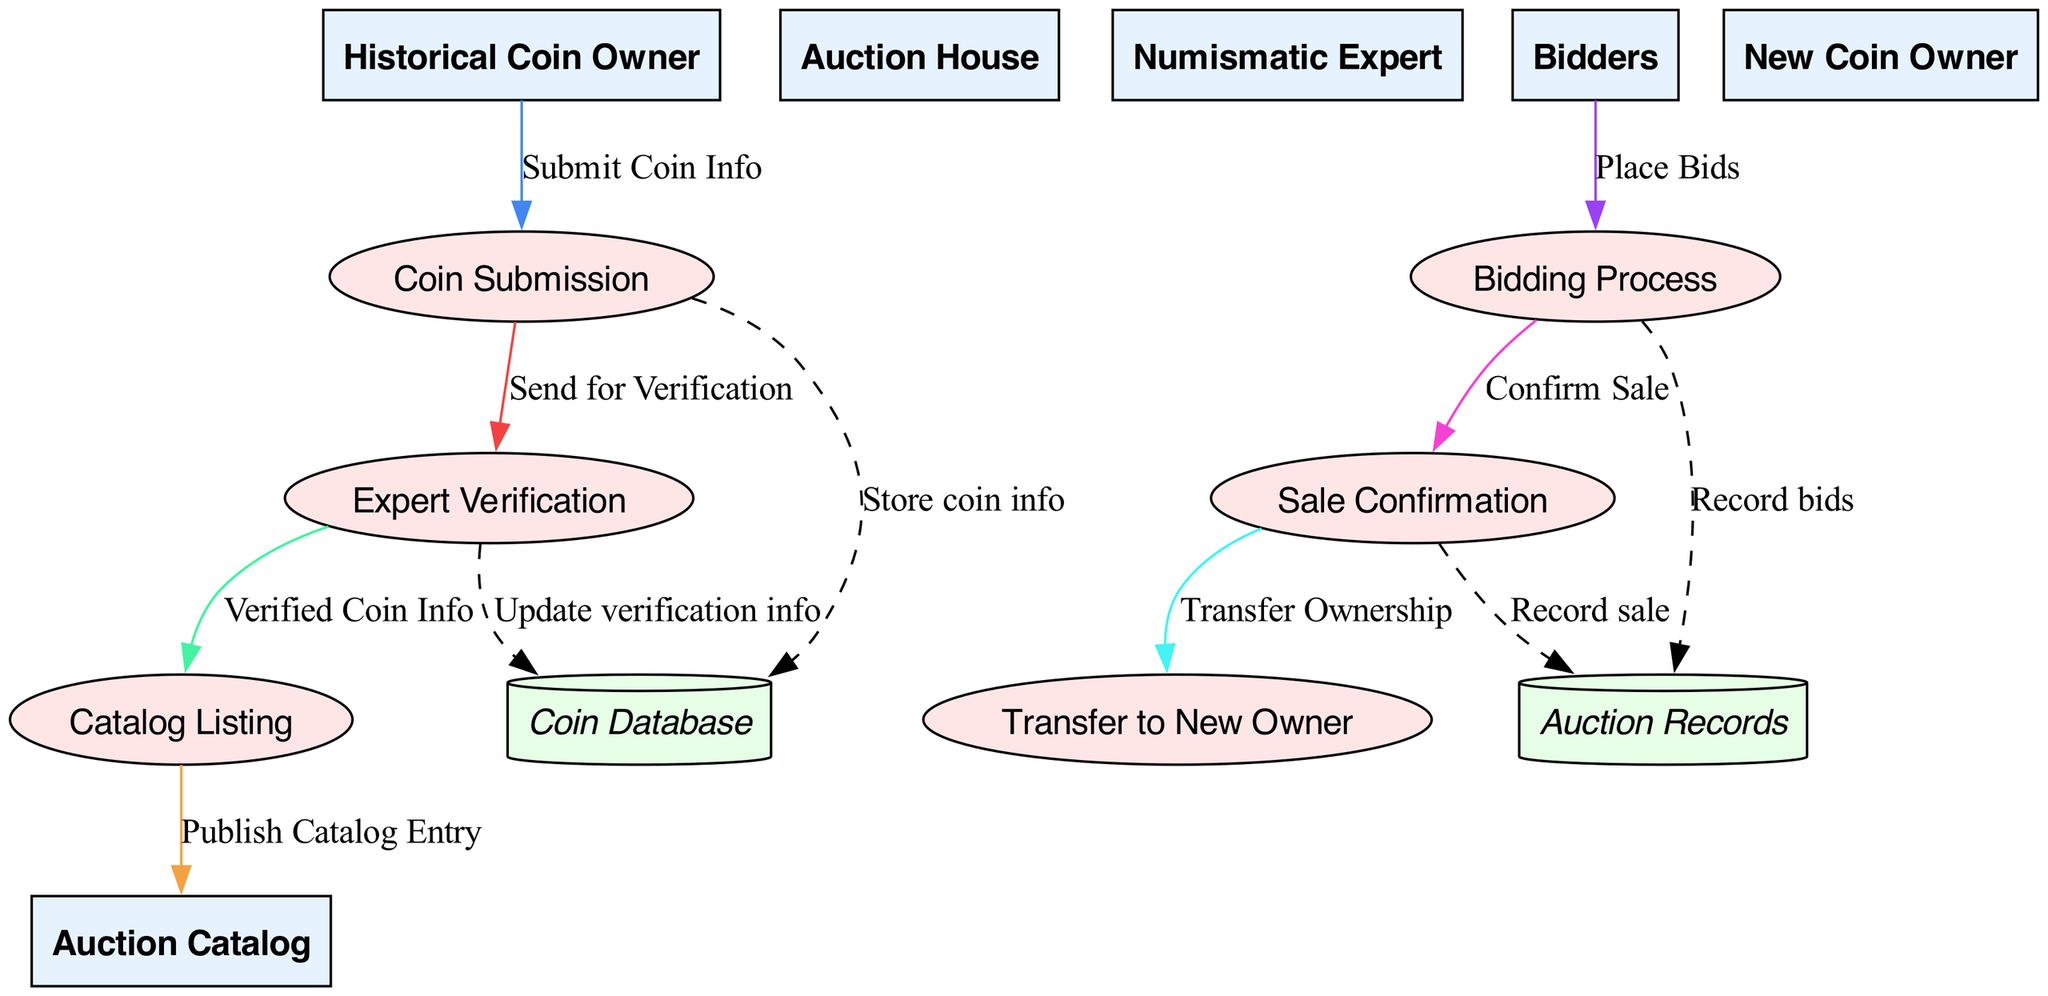What is the first process in the diagram? The first process involves the "Coin Submission," where the historical coin owner submits the coin to the auction house. This is evident from the flow starting with the Historical Coin Owner directing the information to Coin Submission.
Answer: Coin Submission Who verifies the coin's authenticity? The "Numismatic Expert" is responsible for verifying the authenticity of the coin. The diagram shows a flow from the Auction House to the Numismatic Expert for this verification step.
Answer: Numismatic Expert What follows the "Expert Verification" process? After the "Expert Verification" process, the next step is the "Catalog Listing," where verified coins are published in the auction house's catalog. The flow indicates that the verified coin information goes from Expert Verification to Catalog Listing.
Answer: Catalog Listing How many data stores are present in the diagram? The diagram contains two data stores: "Coin Database" and "Auction Records." Each of these data stores is connected to different processes in the flow.
Answer: 2 What is the final step of the information flow in the diagram? The last step in the information flow is "Transfer to New Owner," which occurs after the sale confirmation is completed. This indicates the end of the process where the coin is transferred.
Answer: Transfer to New Owner Which data flow connects the Bidder to the Auction process? The flow labeled as "Place Bids" connects the Bidders to the Bidding Process, indicating that bids are submitted during this phase of the auction.
Answer: Place Bids What data store holds the information about the coin submissions and verifications? The "Coin Database" serves as the data store where details about coin submissions and their verification processes are maintained, as shown by the dashed lines connecting it to the relevant processes.
Answer: Coin Database How does the "Sale Confirmation" process relate to the auction records? The "Sale Confirmation" process is linked to the "Auction Records," which records the details of the sale after a successful bid. This relationship is shown with a dashed line connecting the two.
Answer: Record sale 